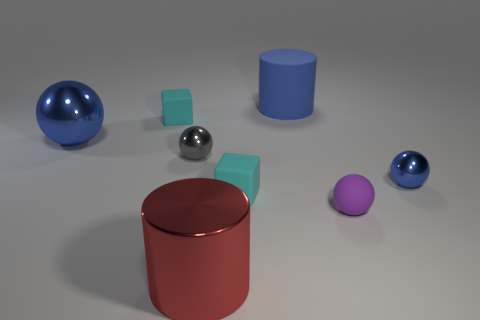Do the big metal sphere and the big rubber cylinder have the same color?
Keep it short and to the point. Yes. What is the shape of the blue rubber thing?
Keep it short and to the point. Cylinder. What number of spheres are either large blue objects or big gray rubber objects?
Offer a terse response. 1. Are there an equal number of matte cylinders that are left of the red metallic cylinder and tiny purple balls that are to the left of the gray ball?
Provide a succinct answer. Yes. There is a metallic object in front of the small metallic thing to the right of the big red metal thing; what number of metal spheres are in front of it?
Give a very brief answer. 0. There is a big metallic object that is the same color as the large rubber cylinder; what is its shape?
Your answer should be compact. Sphere. Does the big rubber cylinder have the same color as the tiny thing on the right side of the small purple thing?
Offer a very short reply. Yes. Is the number of balls that are behind the purple thing greater than the number of big yellow matte cubes?
Your answer should be compact. Yes. What number of things are either cyan rubber things on the right side of the small gray object or matte objects that are left of the purple ball?
Offer a terse response. 3. There is another blue ball that is the same material as the tiny blue ball; what size is it?
Keep it short and to the point. Large. 